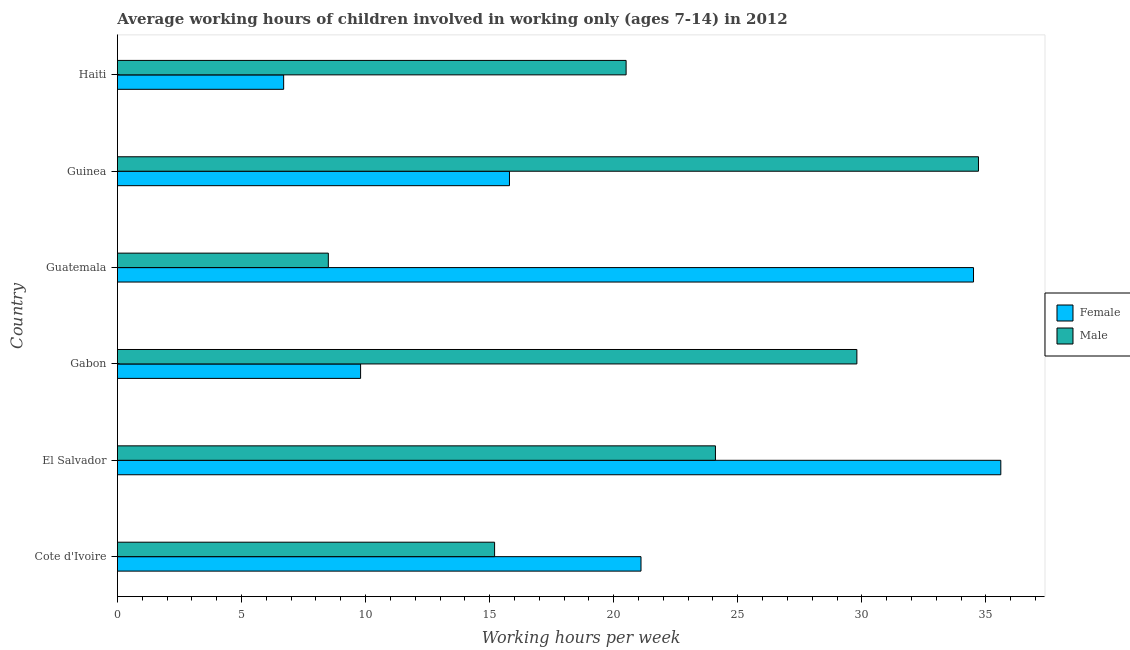How many groups of bars are there?
Make the answer very short. 6. Are the number of bars on each tick of the Y-axis equal?
Provide a short and direct response. Yes. How many bars are there on the 2nd tick from the top?
Ensure brevity in your answer.  2. What is the label of the 3rd group of bars from the top?
Offer a very short reply. Guatemala. In how many cases, is the number of bars for a given country not equal to the number of legend labels?
Provide a succinct answer. 0. What is the average working hour of male children in Cote d'Ivoire?
Ensure brevity in your answer.  15.2. Across all countries, what is the maximum average working hour of male children?
Offer a very short reply. 34.7. In which country was the average working hour of female children maximum?
Your answer should be very brief. El Salvador. In which country was the average working hour of female children minimum?
Ensure brevity in your answer.  Haiti. What is the total average working hour of female children in the graph?
Your response must be concise. 123.5. What is the difference between the average working hour of male children in El Salvador and that in Guatemala?
Your answer should be compact. 15.6. What is the difference between the average working hour of male children in Guinea and the average working hour of female children in Haiti?
Provide a succinct answer. 28. What is the average average working hour of male children per country?
Ensure brevity in your answer.  22.13. In how many countries, is the average working hour of male children greater than 13 hours?
Your answer should be compact. 5. What is the ratio of the average working hour of female children in El Salvador to that in Haiti?
Provide a short and direct response. 5.31. What is the difference between the highest and the lowest average working hour of female children?
Give a very brief answer. 28.9. In how many countries, is the average working hour of female children greater than the average average working hour of female children taken over all countries?
Make the answer very short. 3. What does the 1st bar from the bottom in El Salvador represents?
Your answer should be compact. Female. Are the values on the major ticks of X-axis written in scientific E-notation?
Your response must be concise. No. Does the graph contain any zero values?
Your answer should be very brief. No. Where does the legend appear in the graph?
Offer a very short reply. Center right. What is the title of the graph?
Ensure brevity in your answer.  Average working hours of children involved in working only (ages 7-14) in 2012. What is the label or title of the X-axis?
Offer a terse response. Working hours per week. What is the label or title of the Y-axis?
Offer a very short reply. Country. What is the Working hours per week in Female in Cote d'Ivoire?
Offer a terse response. 21.1. What is the Working hours per week of Male in Cote d'Ivoire?
Your answer should be very brief. 15.2. What is the Working hours per week of Female in El Salvador?
Offer a very short reply. 35.6. What is the Working hours per week in Male in El Salvador?
Offer a very short reply. 24.1. What is the Working hours per week in Male in Gabon?
Your response must be concise. 29.8. What is the Working hours per week in Female in Guatemala?
Provide a succinct answer. 34.5. What is the Working hours per week of Male in Guatemala?
Your answer should be very brief. 8.5. What is the Working hours per week of Female in Guinea?
Give a very brief answer. 15.8. What is the Working hours per week of Male in Guinea?
Ensure brevity in your answer.  34.7. What is the Working hours per week of Female in Haiti?
Make the answer very short. 6.7. What is the Working hours per week of Male in Haiti?
Offer a terse response. 20.5. Across all countries, what is the maximum Working hours per week in Female?
Give a very brief answer. 35.6. Across all countries, what is the maximum Working hours per week of Male?
Keep it short and to the point. 34.7. Across all countries, what is the minimum Working hours per week in Female?
Offer a very short reply. 6.7. Across all countries, what is the minimum Working hours per week in Male?
Provide a short and direct response. 8.5. What is the total Working hours per week of Female in the graph?
Your answer should be compact. 123.5. What is the total Working hours per week in Male in the graph?
Offer a terse response. 132.8. What is the difference between the Working hours per week in Male in Cote d'Ivoire and that in El Salvador?
Your answer should be compact. -8.9. What is the difference between the Working hours per week in Male in Cote d'Ivoire and that in Gabon?
Offer a very short reply. -14.6. What is the difference between the Working hours per week in Female in Cote d'Ivoire and that in Guinea?
Give a very brief answer. 5.3. What is the difference between the Working hours per week in Male in Cote d'Ivoire and that in Guinea?
Make the answer very short. -19.5. What is the difference between the Working hours per week in Female in El Salvador and that in Gabon?
Your response must be concise. 25.8. What is the difference between the Working hours per week of Male in El Salvador and that in Gabon?
Give a very brief answer. -5.7. What is the difference between the Working hours per week of Male in El Salvador and that in Guatemala?
Provide a short and direct response. 15.6. What is the difference between the Working hours per week in Female in El Salvador and that in Guinea?
Your answer should be compact. 19.8. What is the difference between the Working hours per week in Female in El Salvador and that in Haiti?
Your response must be concise. 28.9. What is the difference between the Working hours per week of Male in El Salvador and that in Haiti?
Ensure brevity in your answer.  3.6. What is the difference between the Working hours per week in Female in Gabon and that in Guatemala?
Keep it short and to the point. -24.7. What is the difference between the Working hours per week in Male in Gabon and that in Guatemala?
Ensure brevity in your answer.  21.3. What is the difference between the Working hours per week in Male in Gabon and that in Guinea?
Offer a terse response. -4.9. What is the difference between the Working hours per week of Female in Gabon and that in Haiti?
Your answer should be compact. 3.1. What is the difference between the Working hours per week of Male in Gabon and that in Haiti?
Provide a short and direct response. 9.3. What is the difference between the Working hours per week in Female in Guatemala and that in Guinea?
Offer a very short reply. 18.7. What is the difference between the Working hours per week in Male in Guatemala and that in Guinea?
Your response must be concise. -26.2. What is the difference between the Working hours per week in Female in Guatemala and that in Haiti?
Give a very brief answer. 27.8. What is the difference between the Working hours per week in Female in Guinea and that in Haiti?
Your response must be concise. 9.1. What is the difference between the Working hours per week of Male in Guinea and that in Haiti?
Give a very brief answer. 14.2. What is the difference between the Working hours per week of Female in Cote d'Ivoire and the Working hours per week of Male in El Salvador?
Your response must be concise. -3. What is the difference between the Working hours per week of Female in Cote d'Ivoire and the Working hours per week of Male in Haiti?
Offer a terse response. 0.6. What is the difference between the Working hours per week of Female in El Salvador and the Working hours per week of Male in Guatemala?
Ensure brevity in your answer.  27.1. What is the difference between the Working hours per week in Female in El Salvador and the Working hours per week in Male in Guinea?
Keep it short and to the point. 0.9. What is the difference between the Working hours per week in Female in Gabon and the Working hours per week in Male in Guatemala?
Provide a succinct answer. 1.3. What is the difference between the Working hours per week in Female in Gabon and the Working hours per week in Male in Guinea?
Keep it short and to the point. -24.9. What is the difference between the Working hours per week in Female in Guatemala and the Working hours per week in Male in Guinea?
Offer a very short reply. -0.2. What is the difference between the Working hours per week of Female in Guinea and the Working hours per week of Male in Haiti?
Give a very brief answer. -4.7. What is the average Working hours per week in Female per country?
Make the answer very short. 20.58. What is the average Working hours per week in Male per country?
Make the answer very short. 22.13. What is the difference between the Working hours per week in Female and Working hours per week in Male in El Salvador?
Offer a very short reply. 11.5. What is the difference between the Working hours per week of Female and Working hours per week of Male in Gabon?
Give a very brief answer. -20. What is the difference between the Working hours per week in Female and Working hours per week in Male in Guinea?
Offer a terse response. -18.9. What is the ratio of the Working hours per week of Female in Cote d'Ivoire to that in El Salvador?
Your response must be concise. 0.59. What is the ratio of the Working hours per week of Male in Cote d'Ivoire to that in El Salvador?
Offer a terse response. 0.63. What is the ratio of the Working hours per week of Female in Cote d'Ivoire to that in Gabon?
Offer a terse response. 2.15. What is the ratio of the Working hours per week of Male in Cote d'Ivoire to that in Gabon?
Your answer should be very brief. 0.51. What is the ratio of the Working hours per week in Female in Cote d'Ivoire to that in Guatemala?
Ensure brevity in your answer.  0.61. What is the ratio of the Working hours per week in Male in Cote d'Ivoire to that in Guatemala?
Provide a succinct answer. 1.79. What is the ratio of the Working hours per week in Female in Cote d'Ivoire to that in Guinea?
Offer a very short reply. 1.34. What is the ratio of the Working hours per week of Male in Cote d'Ivoire to that in Guinea?
Your response must be concise. 0.44. What is the ratio of the Working hours per week of Female in Cote d'Ivoire to that in Haiti?
Provide a succinct answer. 3.15. What is the ratio of the Working hours per week of Male in Cote d'Ivoire to that in Haiti?
Provide a short and direct response. 0.74. What is the ratio of the Working hours per week in Female in El Salvador to that in Gabon?
Provide a short and direct response. 3.63. What is the ratio of the Working hours per week in Male in El Salvador to that in Gabon?
Give a very brief answer. 0.81. What is the ratio of the Working hours per week of Female in El Salvador to that in Guatemala?
Your answer should be very brief. 1.03. What is the ratio of the Working hours per week in Male in El Salvador to that in Guatemala?
Offer a terse response. 2.84. What is the ratio of the Working hours per week of Female in El Salvador to that in Guinea?
Your answer should be very brief. 2.25. What is the ratio of the Working hours per week of Male in El Salvador to that in Guinea?
Make the answer very short. 0.69. What is the ratio of the Working hours per week of Female in El Salvador to that in Haiti?
Make the answer very short. 5.31. What is the ratio of the Working hours per week of Male in El Salvador to that in Haiti?
Give a very brief answer. 1.18. What is the ratio of the Working hours per week in Female in Gabon to that in Guatemala?
Your answer should be very brief. 0.28. What is the ratio of the Working hours per week in Male in Gabon to that in Guatemala?
Provide a succinct answer. 3.51. What is the ratio of the Working hours per week of Female in Gabon to that in Guinea?
Give a very brief answer. 0.62. What is the ratio of the Working hours per week in Male in Gabon to that in Guinea?
Your response must be concise. 0.86. What is the ratio of the Working hours per week in Female in Gabon to that in Haiti?
Give a very brief answer. 1.46. What is the ratio of the Working hours per week in Male in Gabon to that in Haiti?
Make the answer very short. 1.45. What is the ratio of the Working hours per week in Female in Guatemala to that in Guinea?
Your answer should be very brief. 2.18. What is the ratio of the Working hours per week in Male in Guatemala to that in Guinea?
Your answer should be compact. 0.24. What is the ratio of the Working hours per week in Female in Guatemala to that in Haiti?
Ensure brevity in your answer.  5.15. What is the ratio of the Working hours per week of Male in Guatemala to that in Haiti?
Ensure brevity in your answer.  0.41. What is the ratio of the Working hours per week of Female in Guinea to that in Haiti?
Offer a very short reply. 2.36. What is the ratio of the Working hours per week of Male in Guinea to that in Haiti?
Offer a very short reply. 1.69. What is the difference between the highest and the second highest Working hours per week of Female?
Your answer should be compact. 1.1. What is the difference between the highest and the second highest Working hours per week of Male?
Ensure brevity in your answer.  4.9. What is the difference between the highest and the lowest Working hours per week of Female?
Keep it short and to the point. 28.9. What is the difference between the highest and the lowest Working hours per week in Male?
Give a very brief answer. 26.2. 